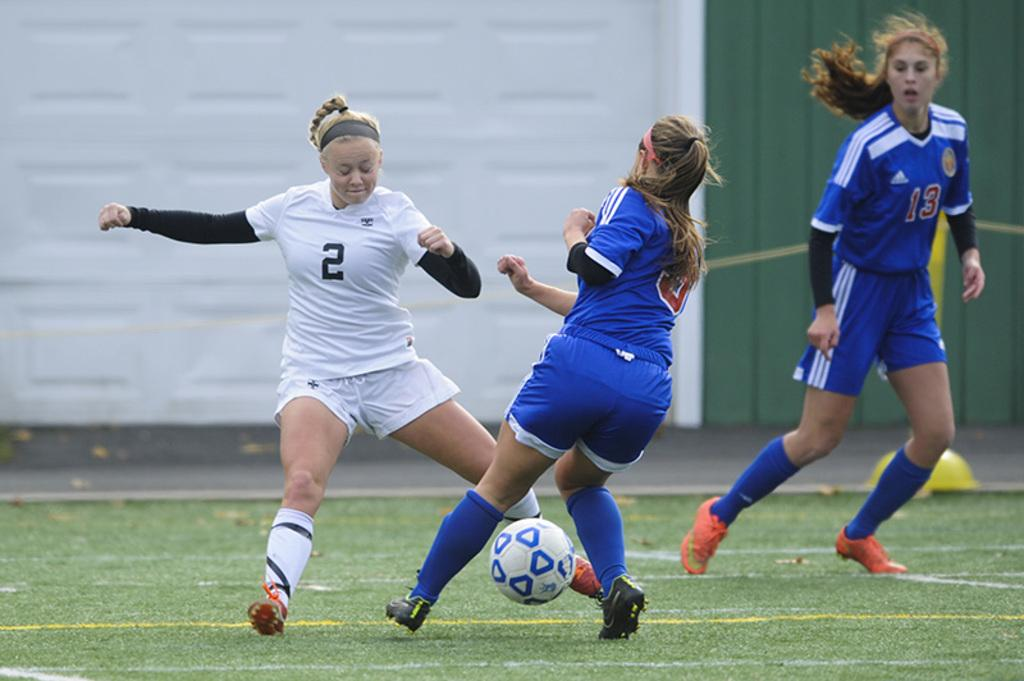Who is the main subject in the image? There is a woman in the image. What is the woman doing in the image? The woman is running on the ground and playing with a ball. What can be seen in the background of the image? There is a road visible in the background of the image. What type of machine is the woman using to play with the ball in the image? There is no machine present in the image; the woman is playing with a ball using her hands and feet. 